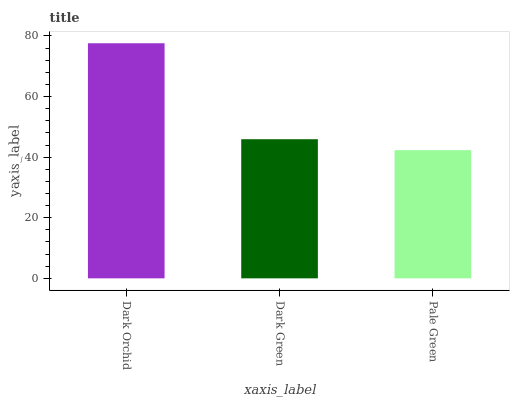Is Pale Green the minimum?
Answer yes or no. Yes. Is Dark Orchid the maximum?
Answer yes or no. Yes. Is Dark Green the minimum?
Answer yes or no. No. Is Dark Green the maximum?
Answer yes or no. No. Is Dark Orchid greater than Dark Green?
Answer yes or no. Yes. Is Dark Green less than Dark Orchid?
Answer yes or no. Yes. Is Dark Green greater than Dark Orchid?
Answer yes or no. No. Is Dark Orchid less than Dark Green?
Answer yes or no. No. Is Dark Green the high median?
Answer yes or no. Yes. Is Dark Green the low median?
Answer yes or no. Yes. Is Pale Green the high median?
Answer yes or no. No. Is Dark Orchid the low median?
Answer yes or no. No. 